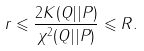Convert formula to latex. <formula><loc_0><loc_0><loc_500><loc_500>r \leqslant \frac { 2 K ( Q | | P ) } { \chi ^ { 2 } ( Q | | P ) } \leqslant R .</formula> 